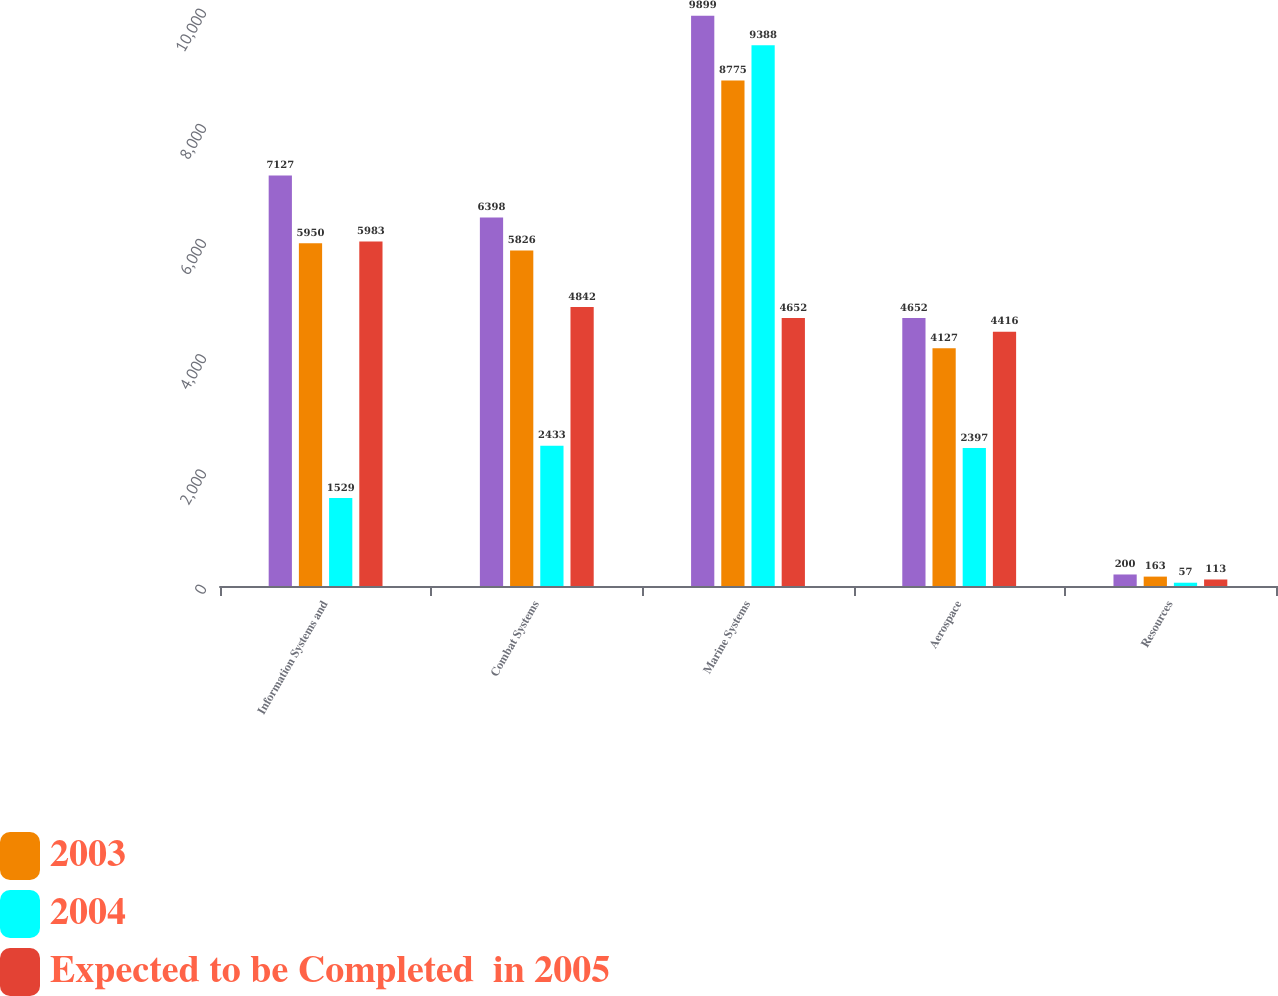Convert chart to OTSL. <chart><loc_0><loc_0><loc_500><loc_500><stacked_bar_chart><ecel><fcel>Information Systems and<fcel>Combat Systems<fcel>Marine Systems<fcel>Aerospace<fcel>Resources<nl><fcel>nan<fcel>7127<fcel>6398<fcel>9899<fcel>4652<fcel>200<nl><fcel>2003<fcel>5950<fcel>5826<fcel>8775<fcel>4127<fcel>163<nl><fcel>2004<fcel>1529<fcel>2433<fcel>9388<fcel>2397<fcel>57<nl><fcel>Expected to be Completed  in 2005<fcel>5983<fcel>4842<fcel>4652<fcel>4416<fcel>113<nl></chart> 